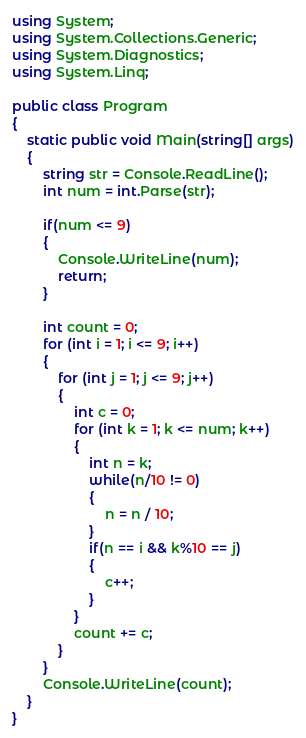<code> <loc_0><loc_0><loc_500><loc_500><_C#_>using System;
using System.Collections.Generic;
using System.Diagnostics;
using System.Linq;

public class Program
{
	static public void Main(string[] args)
	{
		string str = Console.ReadLine();
		int num = int.Parse(str);

		if(num <= 9)
		{
			Console.WriteLine(num);
			return;
		}

		int count = 0;
		for (int i = 1; i <= 9; i++)
		{
			for (int j = 1; j <= 9; j++)
			{
				int c = 0;
				for (int k = 1; k <= num; k++)
				{
					int n = k;
					while(n/10 != 0)
					{
						n = n / 10;
					}
					if(n == i && k%10 == j)
					{
						c++;
					}
				}
				count += c;
			}
		}
		Console.WriteLine(count);
	}
}</code> 